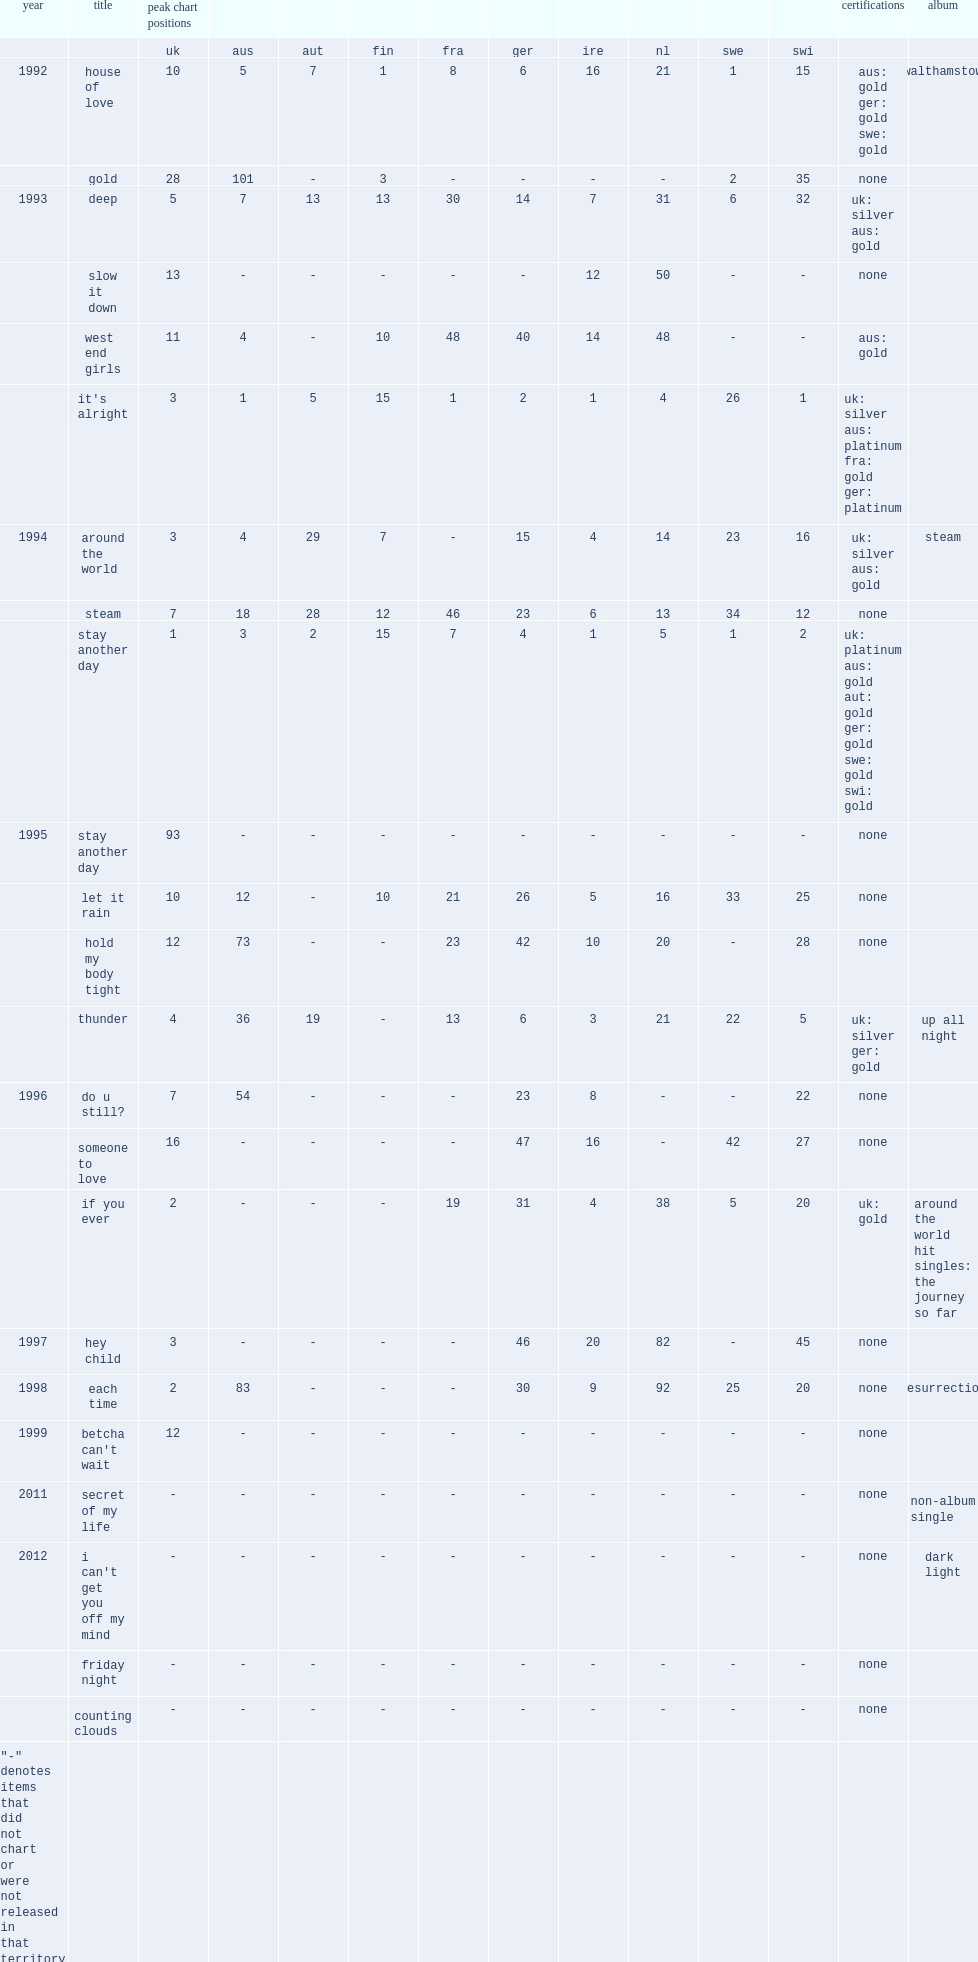Help me parse the entirety of this table. {'header': ['year', 'title', 'peak chart positions', '', '', '', '', '', '', '', '', '', 'certifications', 'album'], 'rows': [['', '', 'uk', 'aus', 'aut', 'fin', 'fra', 'ger', 'ire', 'nl', 'swe', 'swi', '', ''], ['1992', 'house of love', '10', '5', '7', '1', '8', '6', '16', '21', '1', '15', 'aus: gold ger: gold swe: gold', 'walthamstow'], ['', 'gold', '28', '101', '-', '3', '-', '-', '-', '-', '2', '35', 'none', ''], ['1993', 'deep', '5', '7', '13', '13', '30', '14', '7', '31', '6', '32', 'uk: silver aus: gold', ''], ['', 'slow it down', '13', '-', '-', '-', '-', '-', '12', '50', '-', '-', 'none', ''], ['', 'west end girls', '11', '4', '-', '10', '48', '40', '14', '48', '-', '-', 'aus: gold', ''], ['', "it's alright", '3', '1', '5', '15', '1', '2', '1', '4', '26', '1', 'uk: silver aus: platinum fra: gold ger: platinum', ''], ['1994', 'around the world', '3', '4', '29', '7', '-', '15', '4', '14', '23', '16', 'uk: silver aus: gold', 'steam'], ['', 'steam', '7', '18', '28', '12', '46', '23', '6', '13', '34', '12', 'none', ''], ['', 'stay another day', '1', '3', '2', '15', '7', '4', '1', '5', '1', '2', 'uk: platinum aus: gold aut: gold ger: gold swe: gold swi: gold', ''], ['1995', 'stay another day', '93', '-', '-', '-', '-', '-', '-', '-', '-', '-', 'none', ''], ['', 'let it rain', '10', '12', '-', '10', '21', '26', '5', '16', '33', '25', 'none', ''], ['', 'hold my body tight', '12', '73', '-', '-', '23', '42', '10', '20', '-', '28', 'none', ''], ['', 'thunder', '4', '36', '19', '-', '13', '6', '3', '21', '22', '5', 'uk: silver ger: gold', 'up all night'], ['1996', 'do u still?', '7', '54', '-', '-', '-', '23', '8', '-', '-', '22', 'none', ''], ['', 'someone to love', '16', '-', '-', '-', '-', '47', '16', '-', '42', '27', 'none', ''], ['', 'if you ever', '2', '-', '-', '-', '19', '31', '4', '38', '5', '20', 'uk: gold', 'around the world hit singles: the journey so far'], ['1997', 'hey child', '3', '-', '-', '-', '-', '46', '20', '82', '-', '45', 'none', ''], ['1998', 'each time', '2', '83', '-', '-', '-', '30', '9', '92', '25', '20', 'none', 'resurrection'], ['1999', "betcha can't wait", '12', '-', '-', '-', '-', '-', '-', '-', '-', '-', 'none', ''], ['2011', 'secret of my life', '-', '-', '-', '-', '-', '-', '-', '-', '-', '-', 'none', 'non-album single'], ['2012', "i can't get you off my mind", '-', '-', '-', '-', '-', '-', '-', '-', '-', '-', 'none', 'dark light'], ['', 'friday night', '-', '-', '-', '-', '-', '-', '-', '-', '-', '-', 'none', ''], ['', 'counting clouds', '-', '-', '-', '-', '-', '-', '-', '-', '-', '-', 'none', ''], ['"-" denotes items that did not chart or were not released in that territory', '', '', '', '', '', '', '', '', '', '', '', '', '']]} What was the peak chart position on the uk of "stay another day" ? 1.0. 